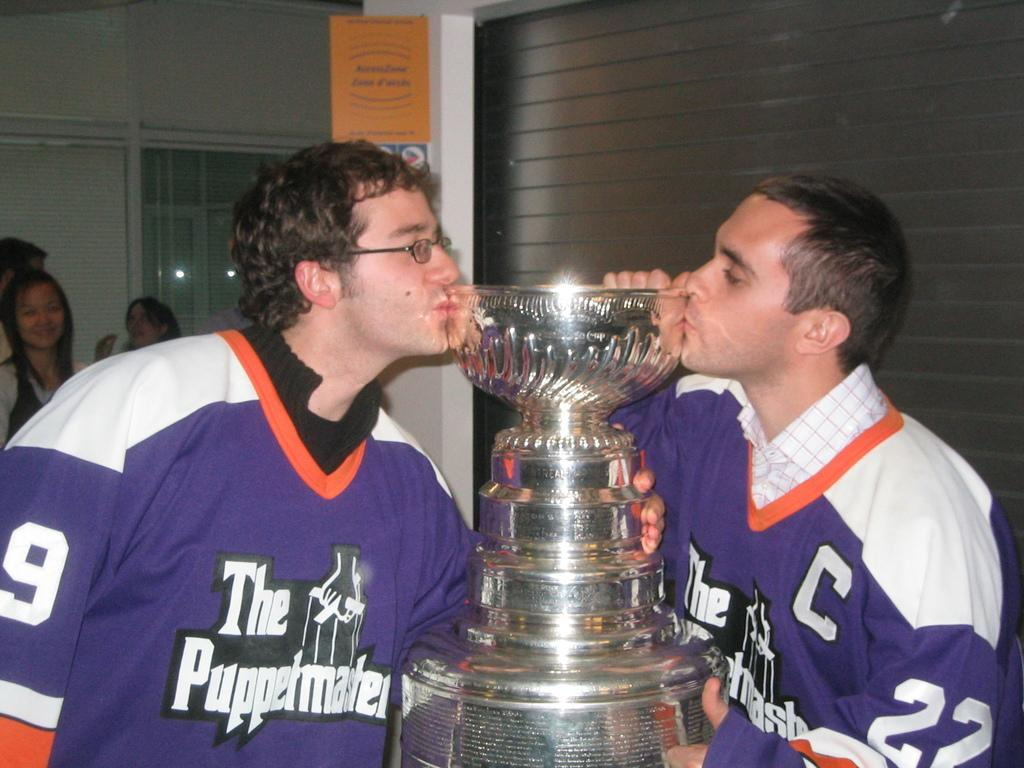<image>
Write a terse but informative summary of the picture. Two hockey players kissing a trophy, one of hem has C # 22, and the other on the left is # 9 for The Puppetmasters Team. 